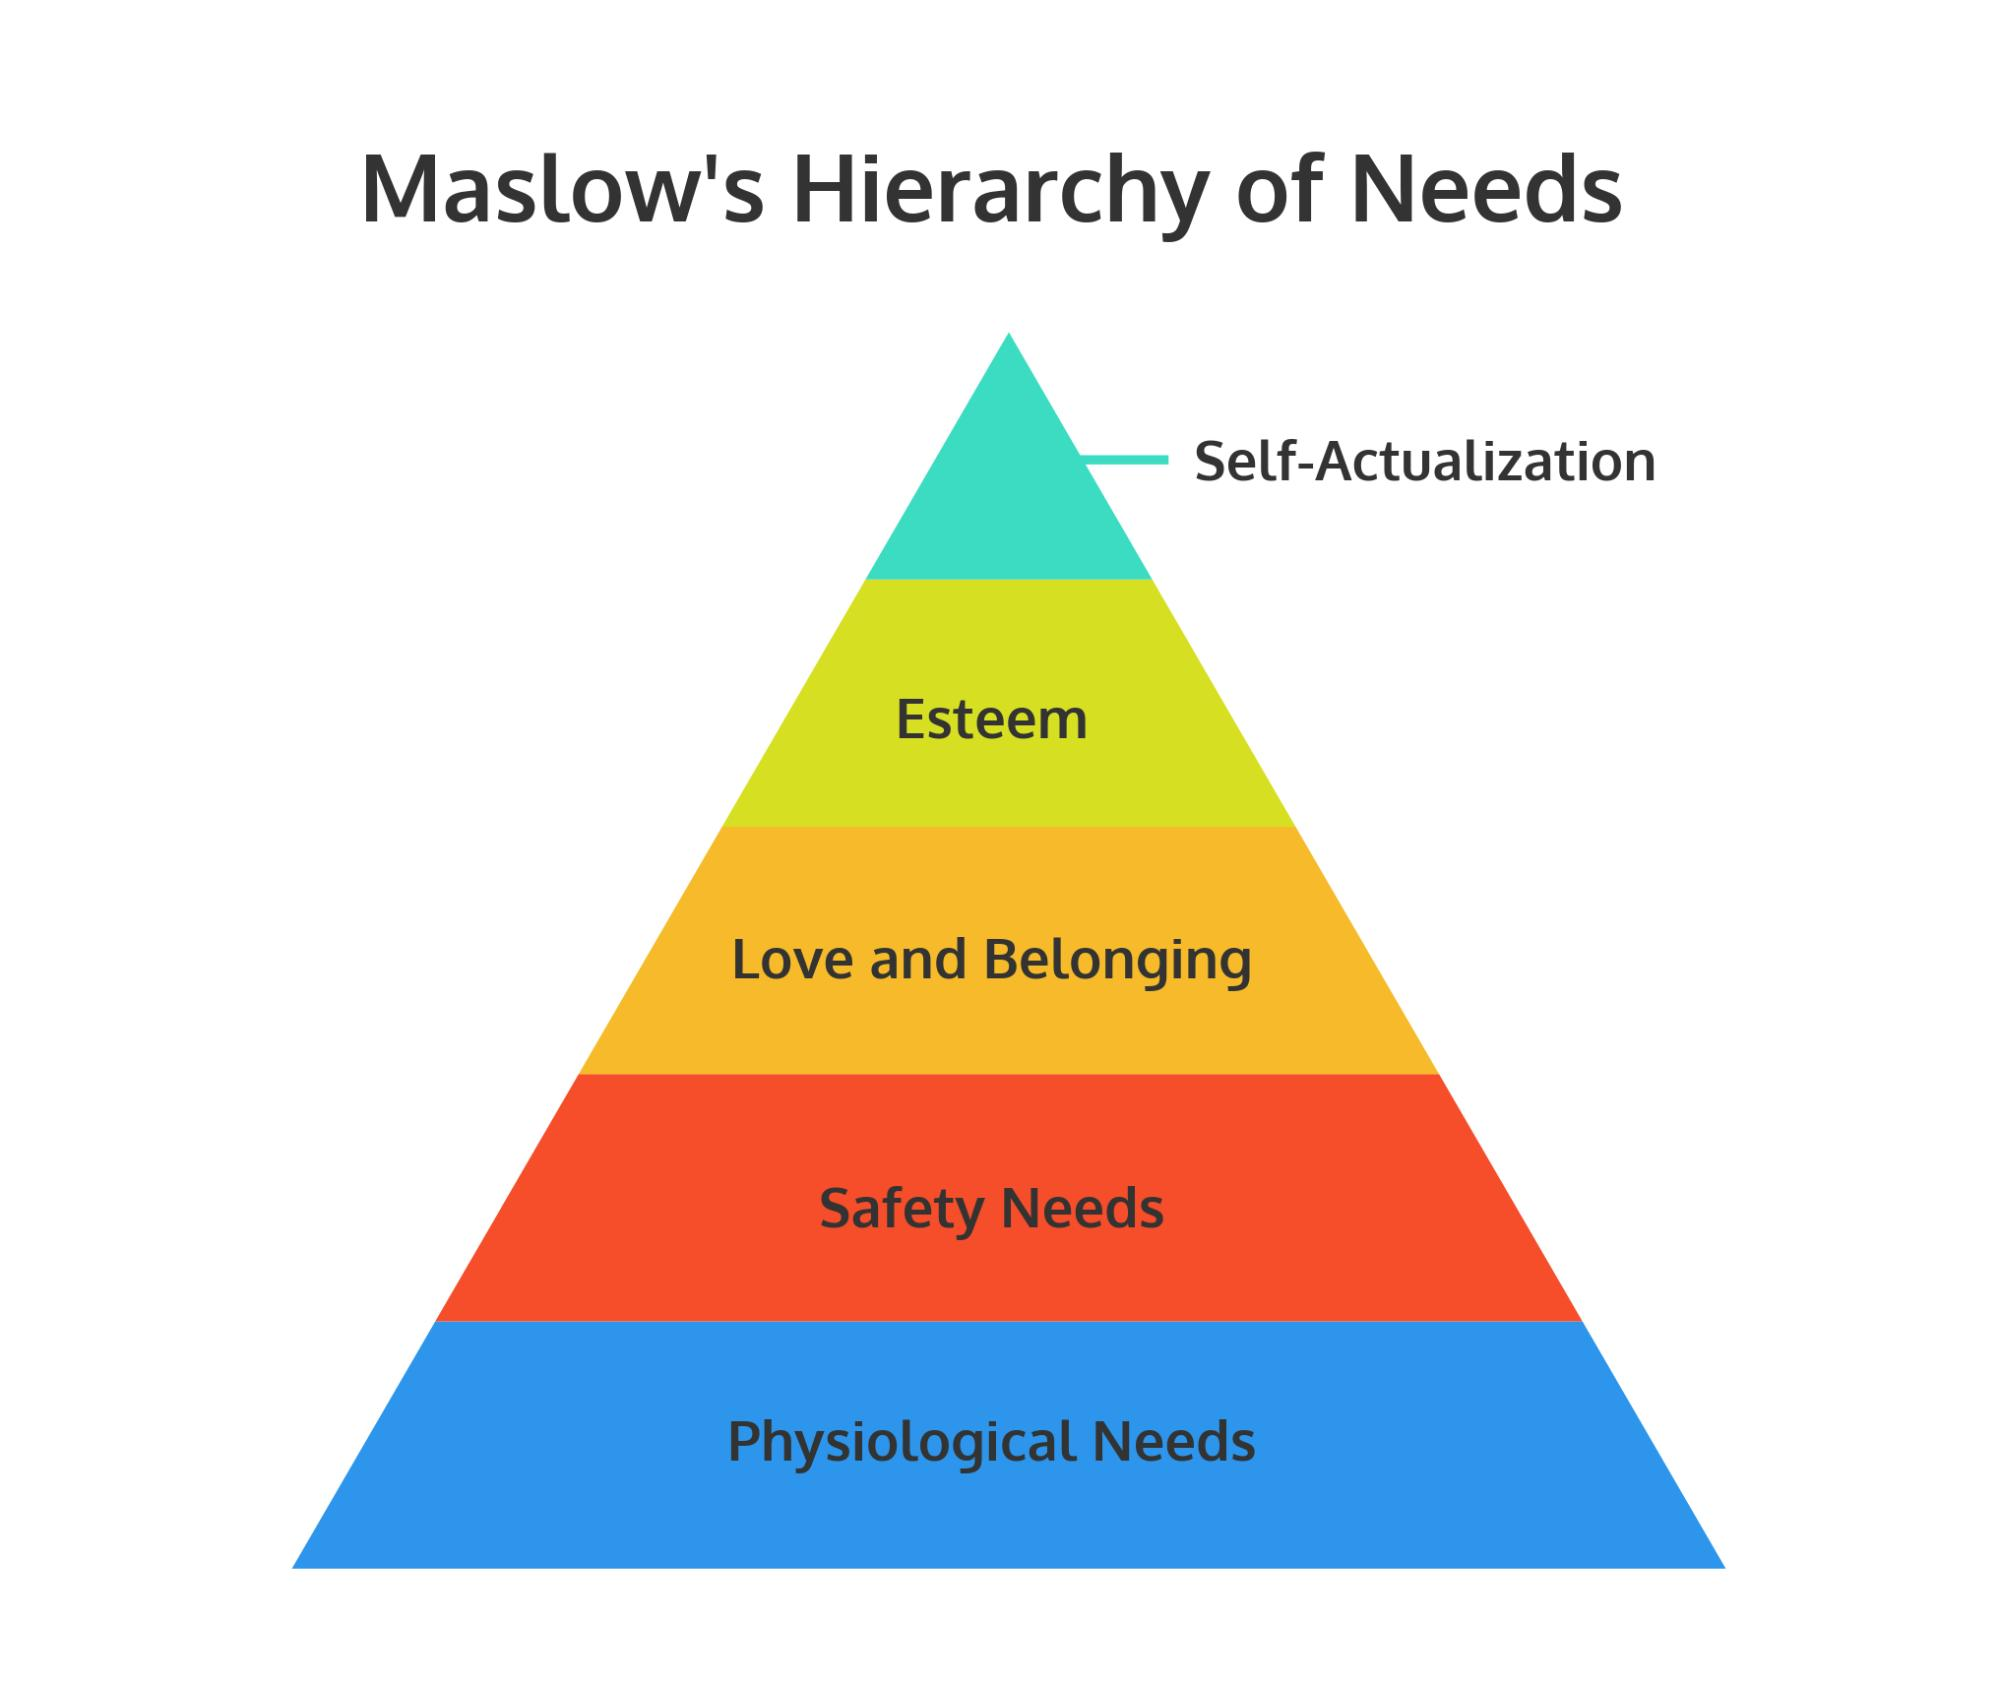Give some essential details in this illustration. The Maslow's hierarchy of needs was depicted in the shape of a triangle. The color of the block representing "safety needs" is red. 